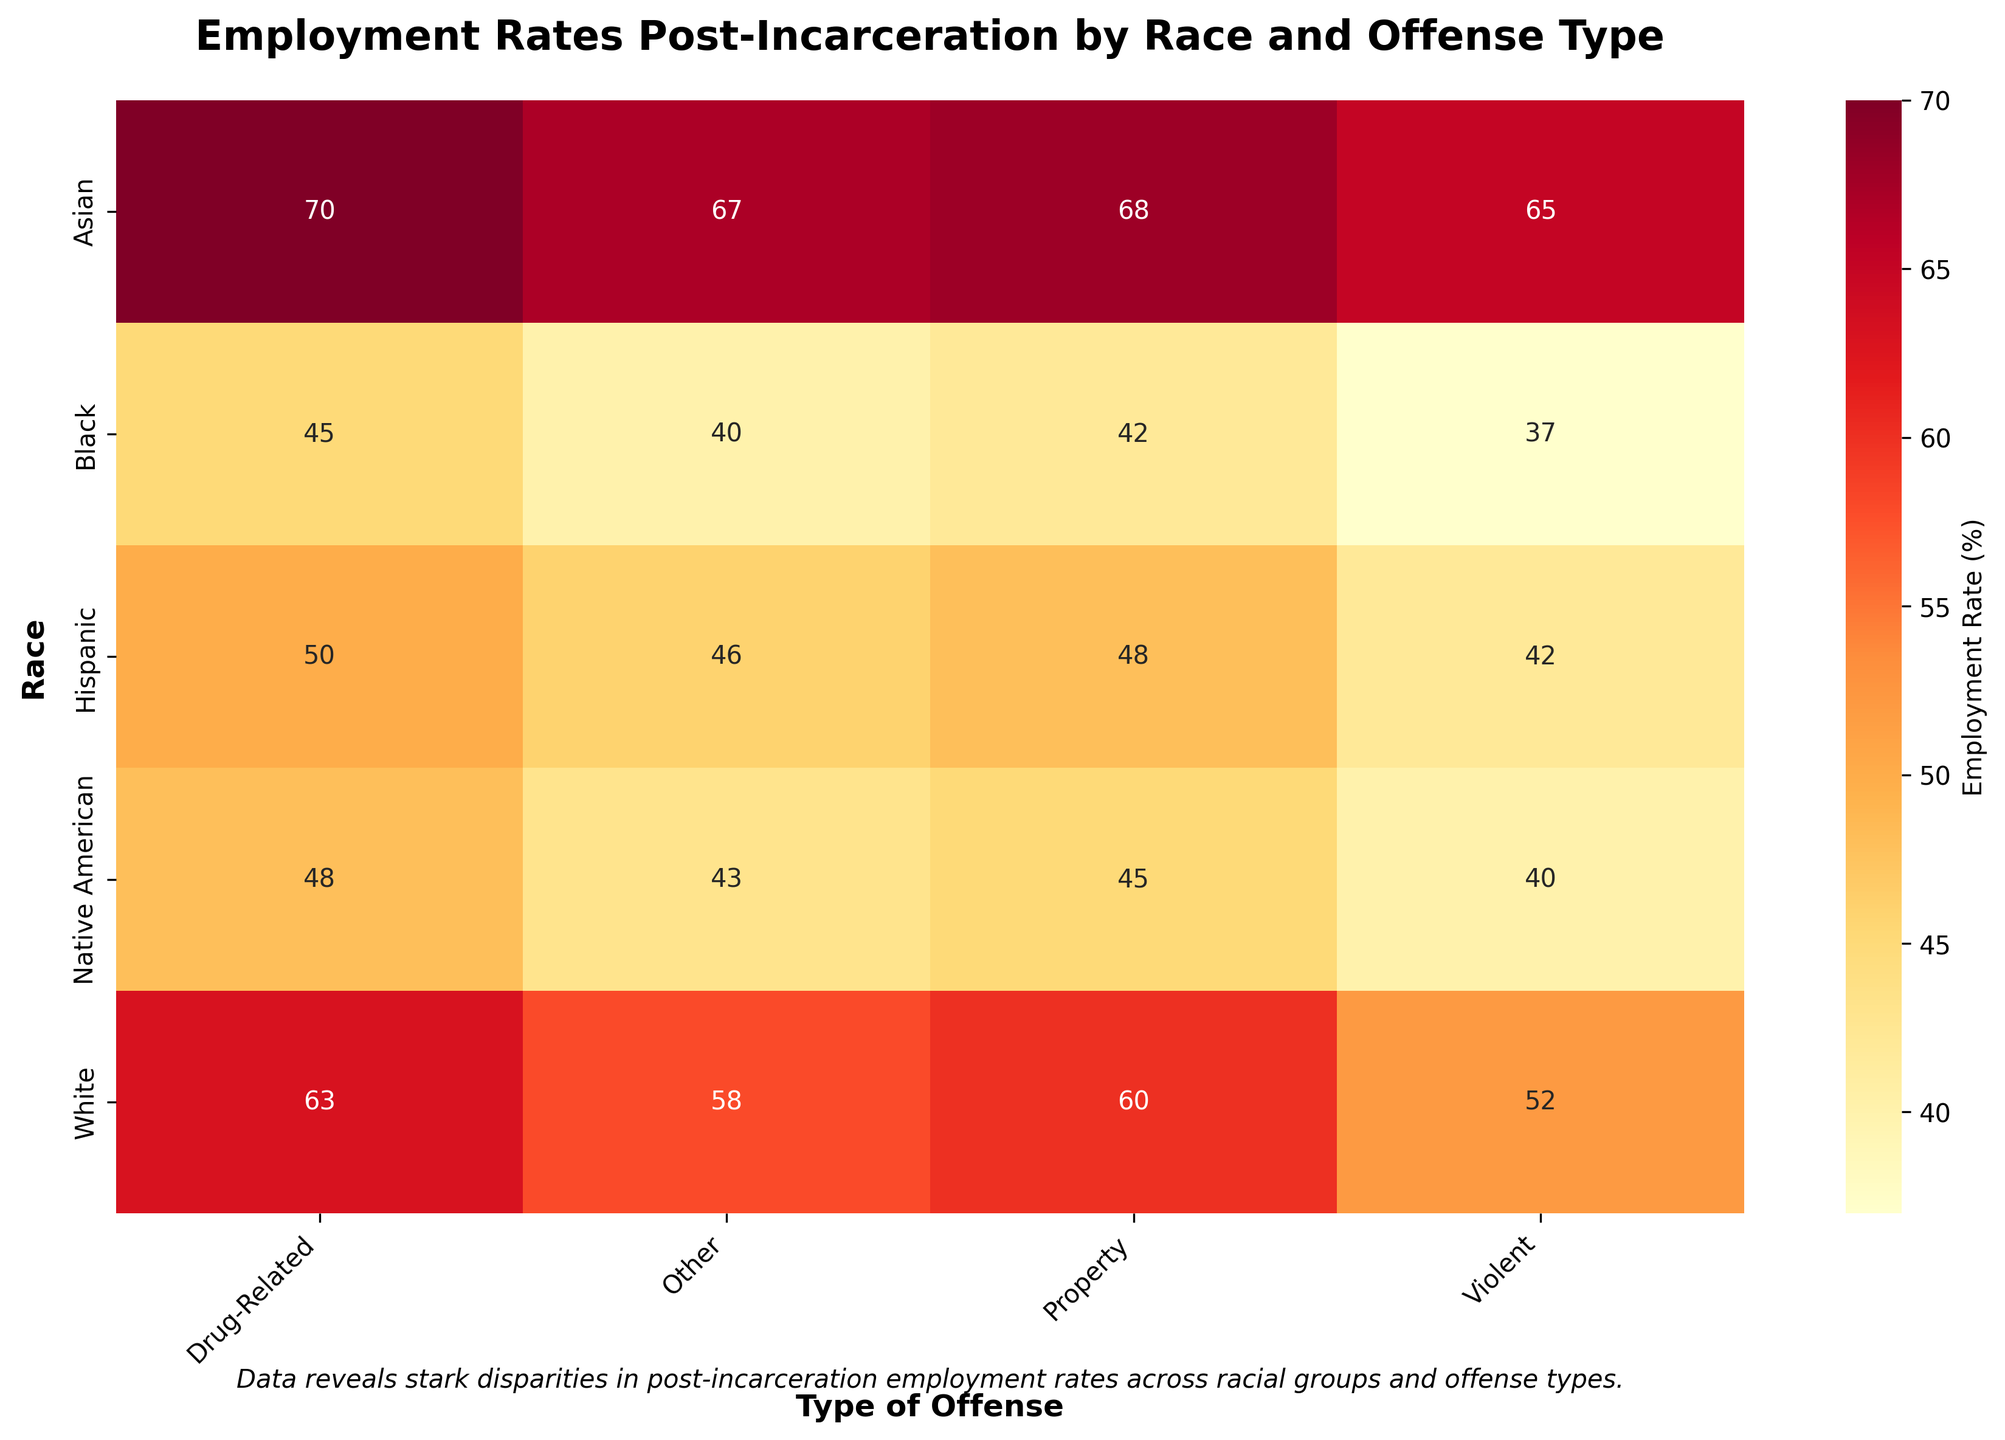What is the employment rate for Asian individuals with property offenses? The heatmap shows data for employment rates post-incarceration by race and type of offense. Locate the cell corresponding to "Asian" on the y-axis and "Property" on the x-axis.
Answer: 68 What is the highest employment rate among all racial groups and types of offenses? Look for the cell with the highest value on the heatmap.
Answer: 70 How much lower is the post-incarceration employment rate for Black individuals with violent offenses compared to White individuals with violent offenses? Find the employment rates for Black and White individuals with violent offenses and subtract the Black rate from the White rate. (52 - 37)
Answer: 15 Which racial group has the lowest average employment rate post-incarceration across all offense types? Calculate the average employment rate for each racial group and compare them. Black: (45+37+42+40)/4 = 41; White: (63+52+60+58)/4 = 58.25; Hispanic: (50+42+48+46)/4 = 46.5; Asian: (70+65+68+67)/4 = 67.5; Native American: (48+40+45+43)/4 = 44.
Answer: Black What is the title of the heatmap? Read the title directly from the heatmap.
Answer: Employment Rates Post-Incarceration by Race and Offense Type Which type of offense has the highest post-incarceration employment rate for Native American individuals? Locate the row for Native American individuals and find the highest value across the columns.
Answer: Drug-Related Between Hispanic and Native American individuals with "Other" offenses, who has a higher employment rate post-incarceration? Compare the employment rates for both groups in the "Other" column.
Answer: Hispanic Does any racial group have identical employment rates for more than one type of offense? If so, which group and which offenses? Examine each row to see if there are any repeated values. Native American individuals have identical employment rates for "Other" and "Violent" offenses (both 43).
Answer: Native American, Violent and Other What is the color representing the highest employment rate on the heatmap? Identify the color of the cell with the highest employment rate value.
Answer: Dark Red What is the employment rate for Hispanic individuals with drug-related offenses? Find the cell corresponding to "Hispanic" on the y-axis and "Drug-Related" on the x-axis.
Answer: 50 